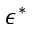Convert formula to latex. <formula><loc_0><loc_0><loc_500><loc_500>\epsilon ^ { * }</formula> 